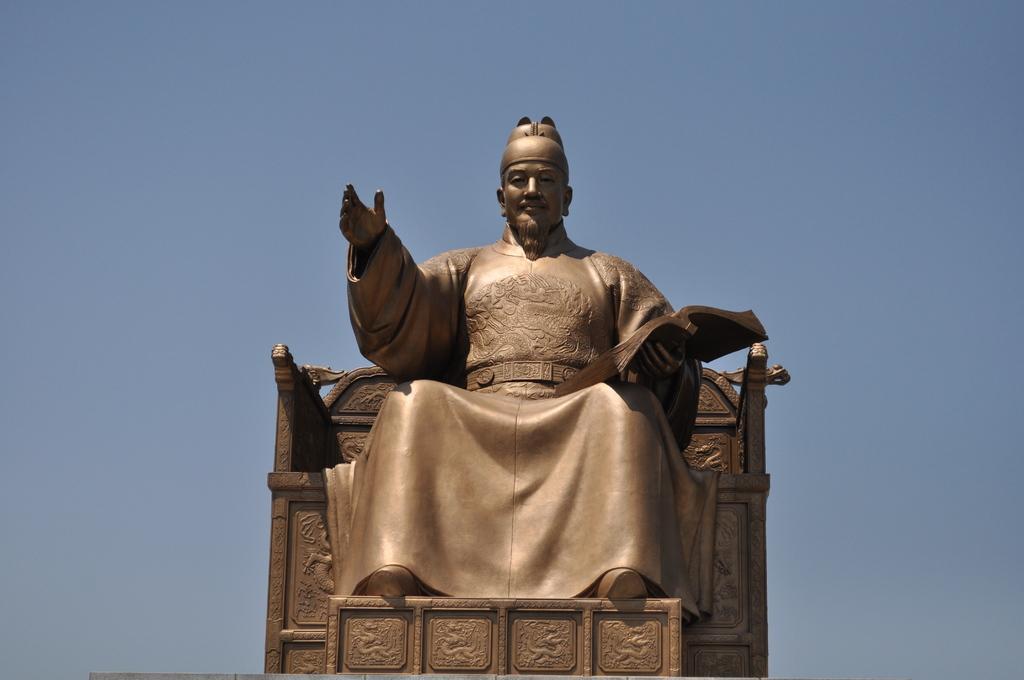Can you describe this image briefly? In this picture I can see there is a statue of a person sitting on the chair and he is wearing a long shirt, he has beard and mustache and there is some sculpture on the chair and there is a foot rest and the sky is clear. 